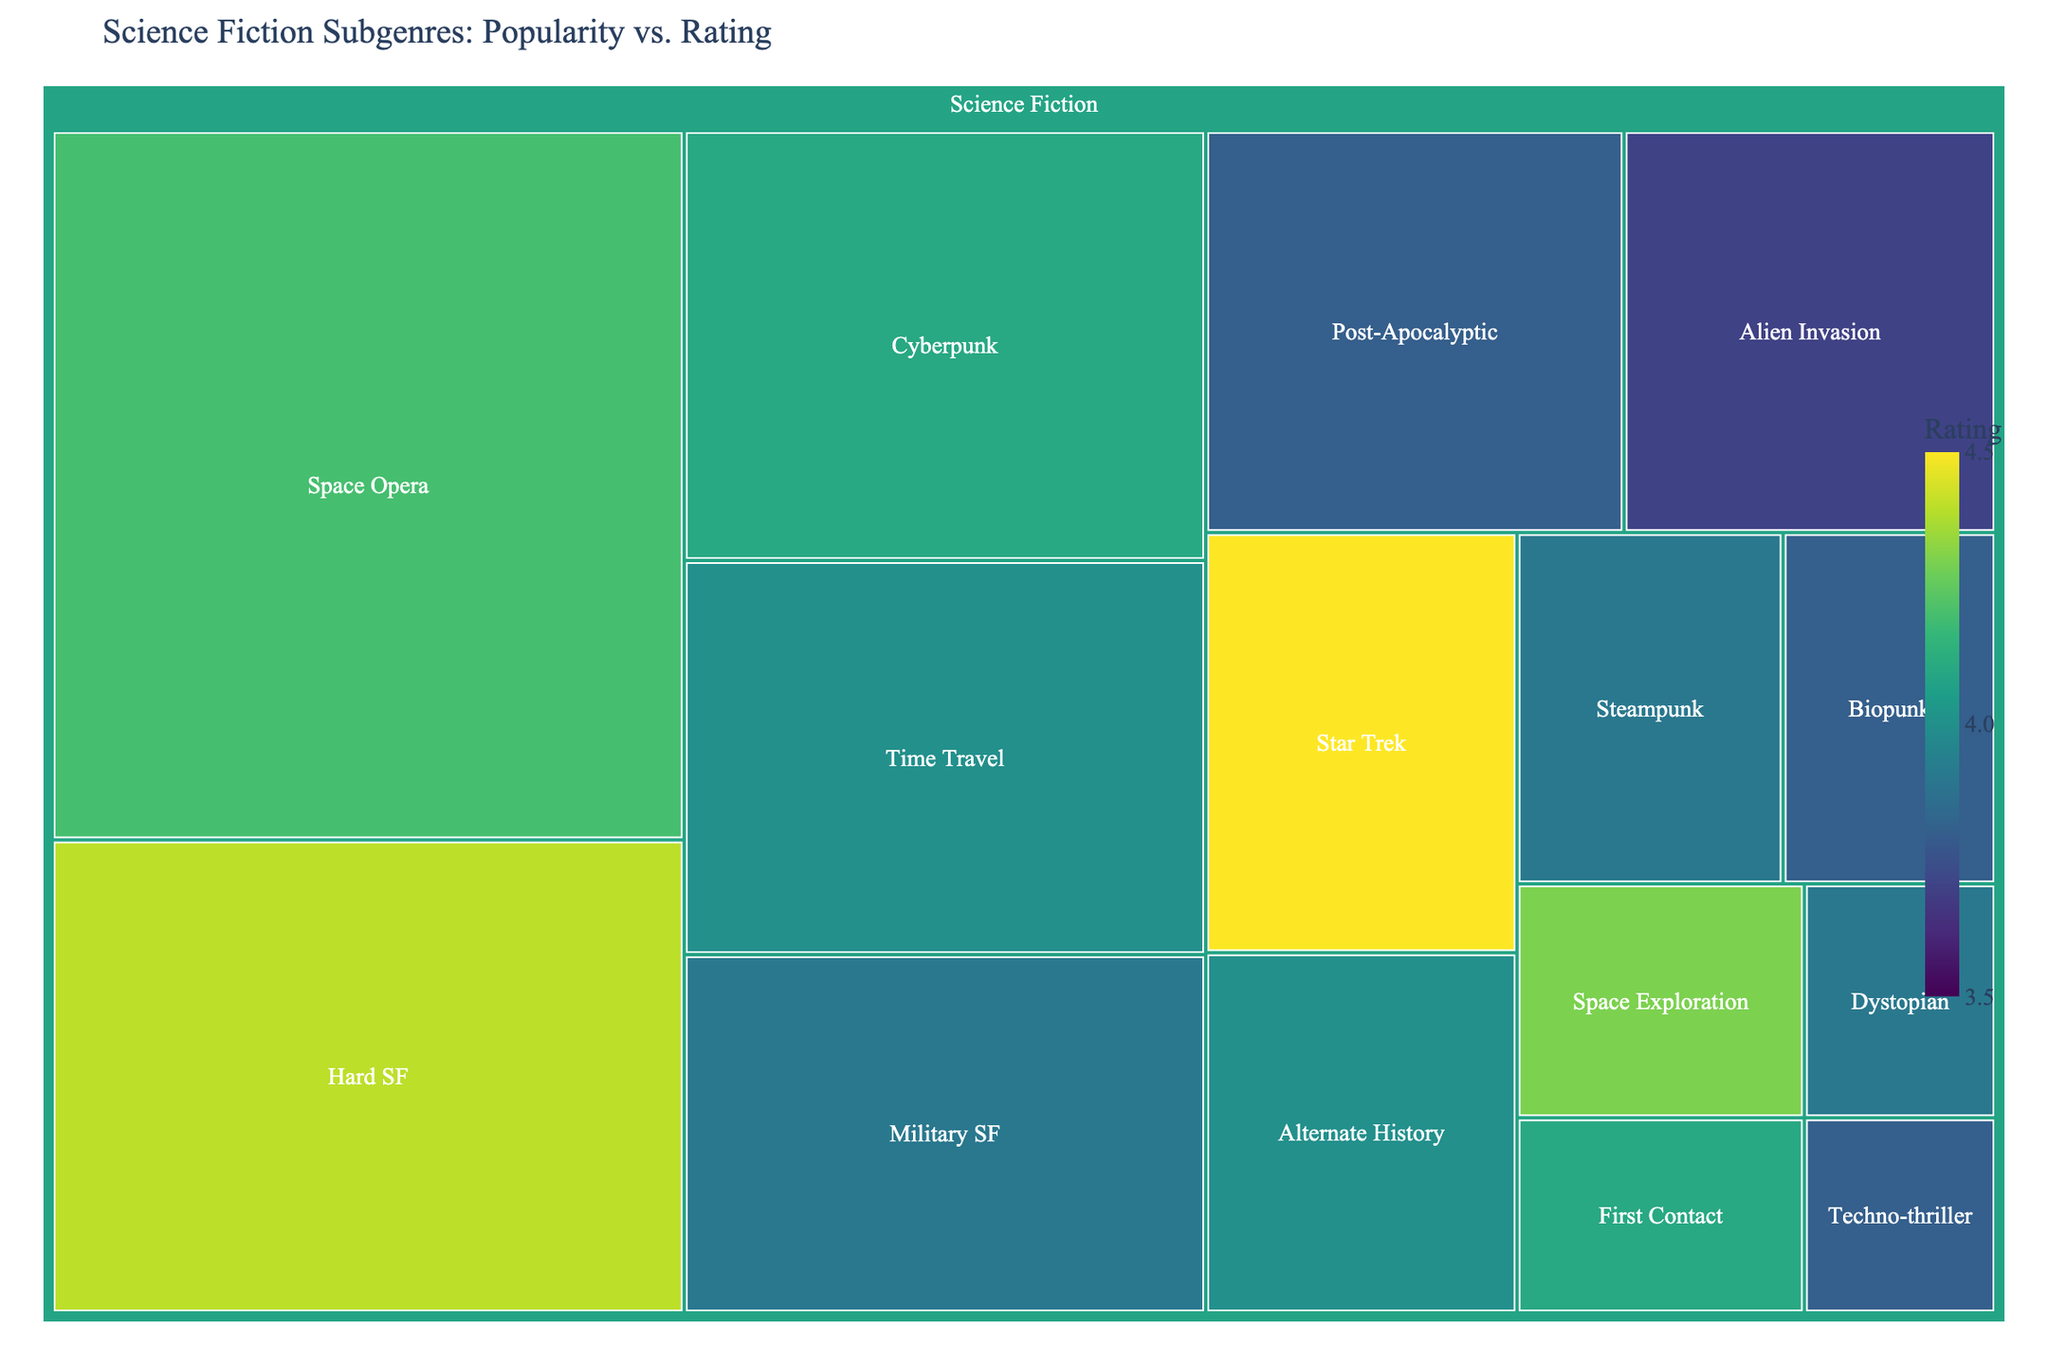What is the title of the Treemap? The title is typically at the top of the figure. In this case, it reads "Science Fiction Subgenres: Popularity vs. Rating".
Answer: Science Fiction Subgenres: Popularity vs. Rating Which subgenre has the highest rating? By observing the color and checking the hover data, the darkest (richest) color corresponds to the highest rating. "Star Trek" has the highest rating of 4.5.
Answer: Star Trek What are the sales for the "Space Opera" subgenre? Hover over the "Space Opera" section on the Treemap. The hover data displays the sales as 1,200,000.
Answer: 1,200,000 How many subgenres are there in total? Each rectangle within the Treemap represents a subgenre. Counting them reveals there are 15 subgenres.
Answer: 15 Which subgenre has the lowest sales? Locate the smallest rectangle. "Techno-thriller" has the smallest size with sales of 100,000.
Answer: Techno-thriller What is the average rating of the subgenres with sales greater than 500,000? Identify subgenres with sales greater than 500,000: Space Opera (4.2), Hard SF (4.4), Cyberpunk (4.1), Time Travel (4.0). Average rating = (4.2 + 4.4 + 4.1 + 4.0) / 4 = 4.175.
Answer: 4.175 Which two subgenres have nearly similar sales figures? Compare sizes visually. "Time Travel" and "Military SF" appear close. "Time Travel" has 550,000 and "Military SF" has 500,000 in sales.
Answer: Time Travel and Military SF Which subgenre with less than 200,000 in sales has the highest rating? Identify subgenres with sales less than 200,000: Space Exploration (4.3) and First Contact (4.1). The highest rating among them is "Space Exploration" with 4.3.
Answer: Space Exploration How do Post-Apocalyptic and Alien Invasion subgenres compare in terms of rating and sales? "Post-Apocalyptic" has sales of 450,000 and rating of 3.8. "Alien Invasion" has sales of 400,000 and rating of 3.7. "Post-Apocalyptic" is slightly higher in both sales and rating.
Answer: Post-Apocalyptic has higher sales and rating What is the total sales for all subgenres combined? Sum all sales figures: 1,200,000 + 800,000 + 600,000 + 550,000 + 500,000 + 450,000 + 400,000 + 350,000 + 300,000 + 250,000 + 200,000 + 180,000 + 150,000 + 120,000 + 100,000 = 6,150,000.
Answer: 6,150,000 